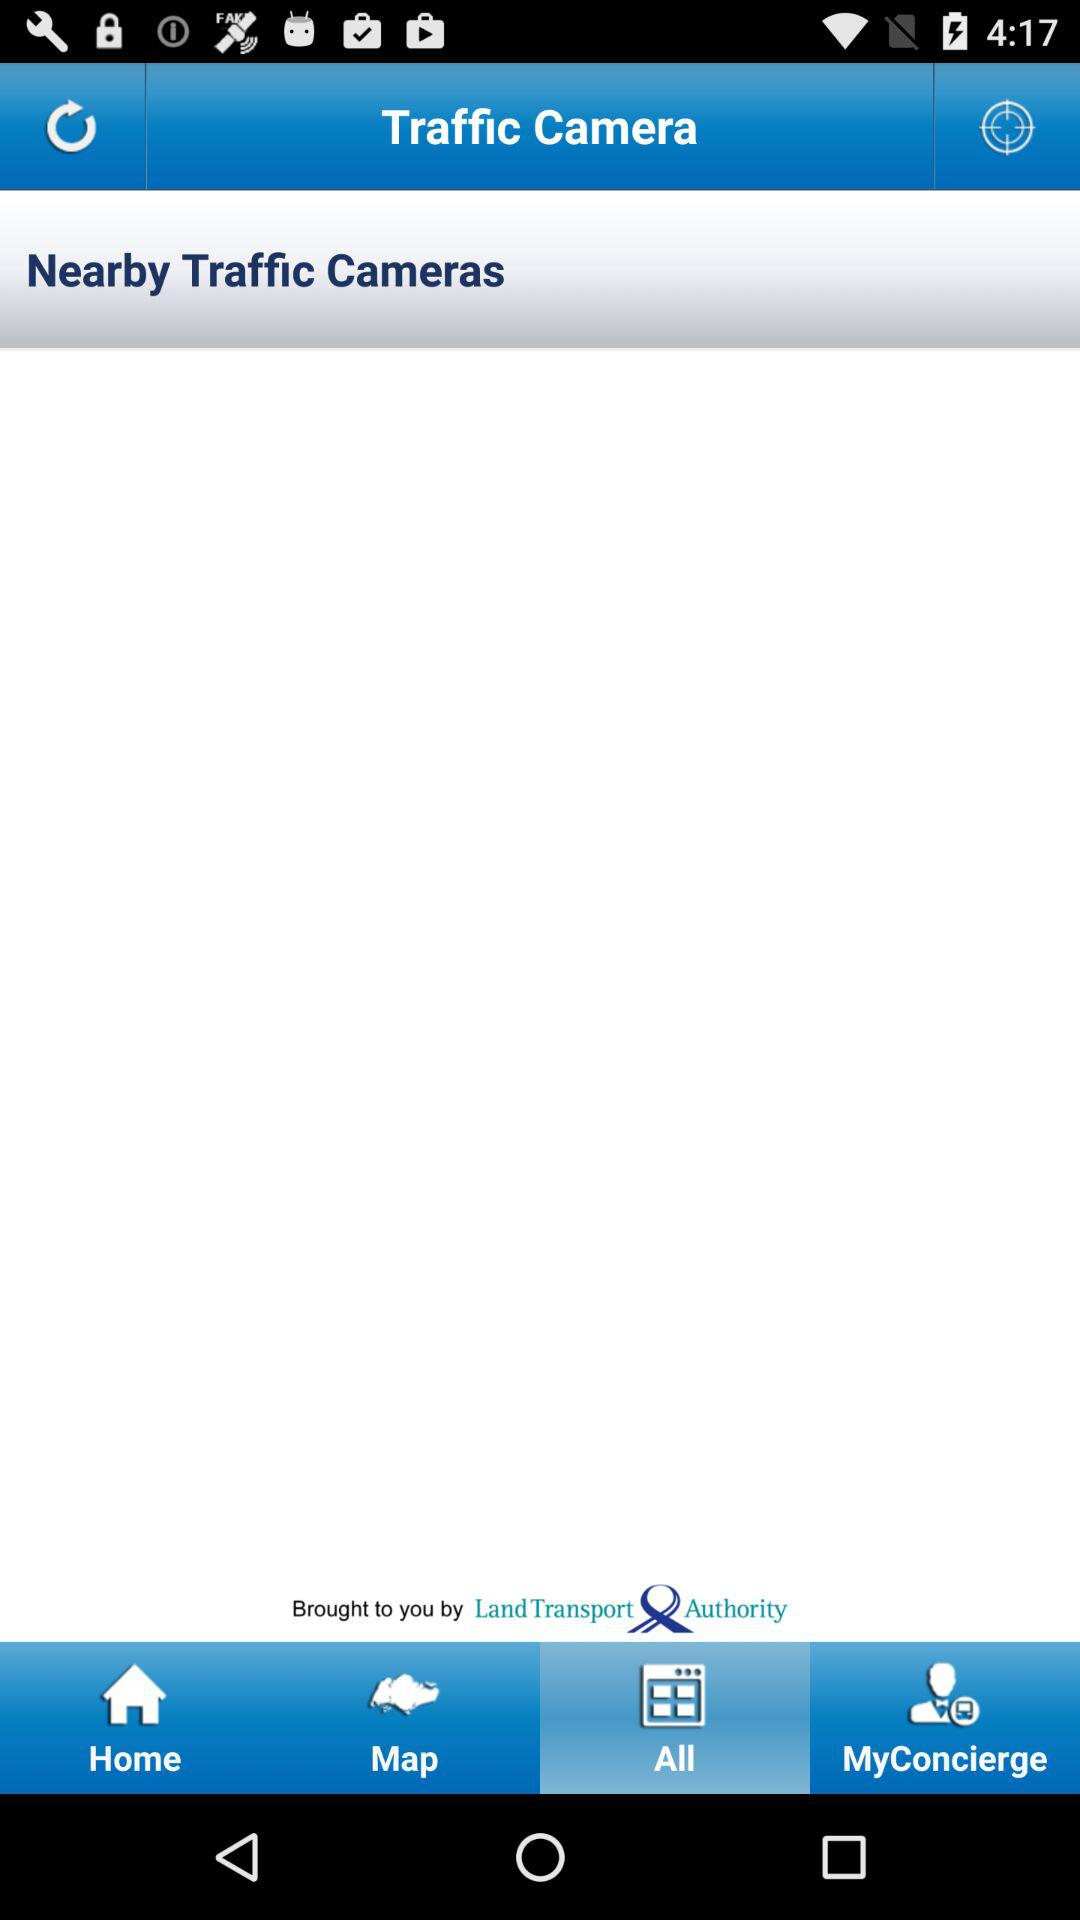Which tab is selected? The selected tab is "All". 